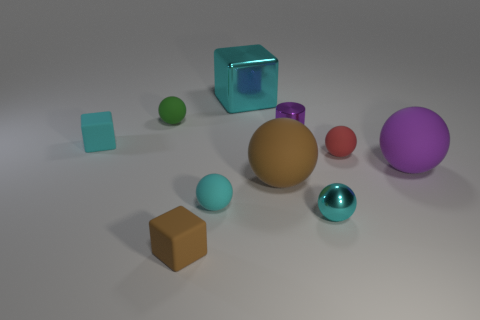Is the material of the green object the same as the purple ball?
Give a very brief answer. Yes. How many other objects are the same material as the small cyan cube?
Ensure brevity in your answer.  6. How many matte objects are both to the right of the purple metal cylinder and in front of the red rubber thing?
Your answer should be very brief. 1. What color is the large shiny object?
Your response must be concise. Cyan. What is the material of the large brown thing that is the same shape as the large purple thing?
Your answer should be very brief. Rubber. Is there any other thing that has the same material as the red thing?
Your answer should be compact. Yes. Do the large metallic block and the metallic cylinder have the same color?
Give a very brief answer. No. What shape is the brown matte thing on the right side of the metallic object that is to the left of the brown rubber ball?
Make the answer very short. Sphere. What is the shape of the tiny brown thing that is made of the same material as the red sphere?
Offer a very short reply. Cube. How many other objects are there of the same shape as the large brown object?
Your answer should be very brief. 5. 